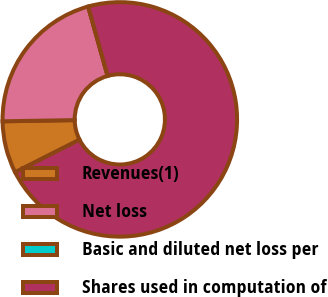Convert chart. <chart><loc_0><loc_0><loc_500><loc_500><pie_chart><fcel>Revenues(1)<fcel>Net loss<fcel>Basic and diluted net loss per<fcel>Shares used in computation of<nl><fcel>7.19%<fcel>20.91%<fcel>0.0%<fcel>71.9%<nl></chart> 